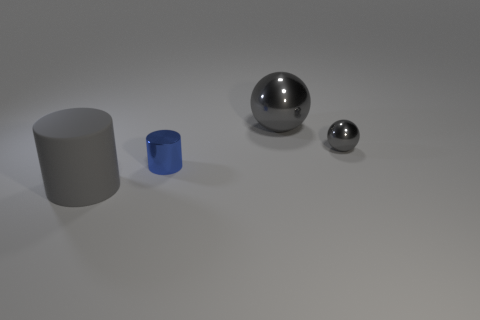Is there a yellow shiny cube of the same size as the shiny cylinder?
Offer a terse response. No. Does the small shiny thing on the right side of the large gray shiny thing have the same color as the large object that is to the left of the blue metal cylinder?
Your answer should be compact. Yes. Is there a metallic object of the same color as the large rubber object?
Keep it short and to the point. Yes. There is a small metal thing that is to the left of the tiny sphere; what shape is it?
Your answer should be very brief. Cylinder. There is a tiny gray thing; is its shape the same as the tiny thing on the left side of the tiny gray metallic object?
Offer a terse response. No. There is a gray thing that is both on the left side of the small gray object and behind the large cylinder; what size is it?
Provide a short and direct response. Large. The metal thing that is both left of the small gray sphere and behind the tiny cylinder is what color?
Your answer should be very brief. Gray. Is there anything else that is the same material as the gray cylinder?
Make the answer very short. No. Are there fewer cylinders that are right of the matte cylinder than objects that are behind the blue object?
Keep it short and to the point. Yes. Is there any other thing that has the same color as the tiny metal cylinder?
Your answer should be very brief. No. 